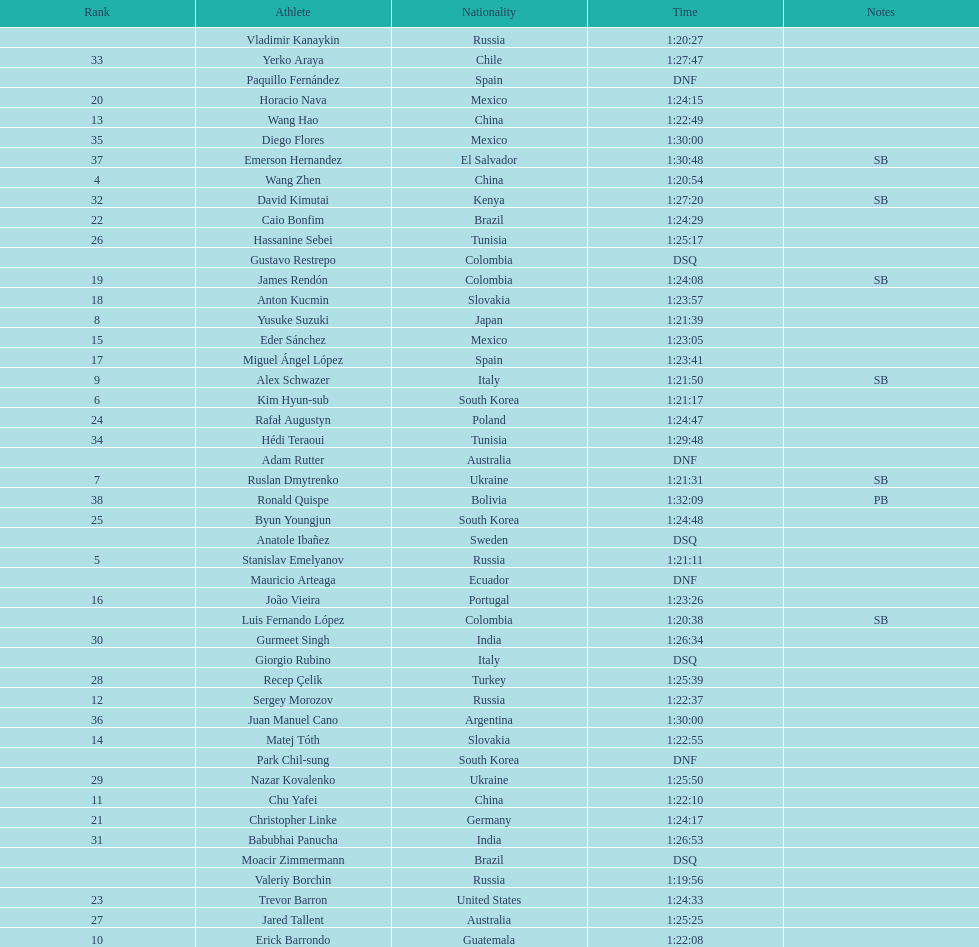What is the total count of athletes included in the rankings chart, including those classified as dsq & dnf? 46. 